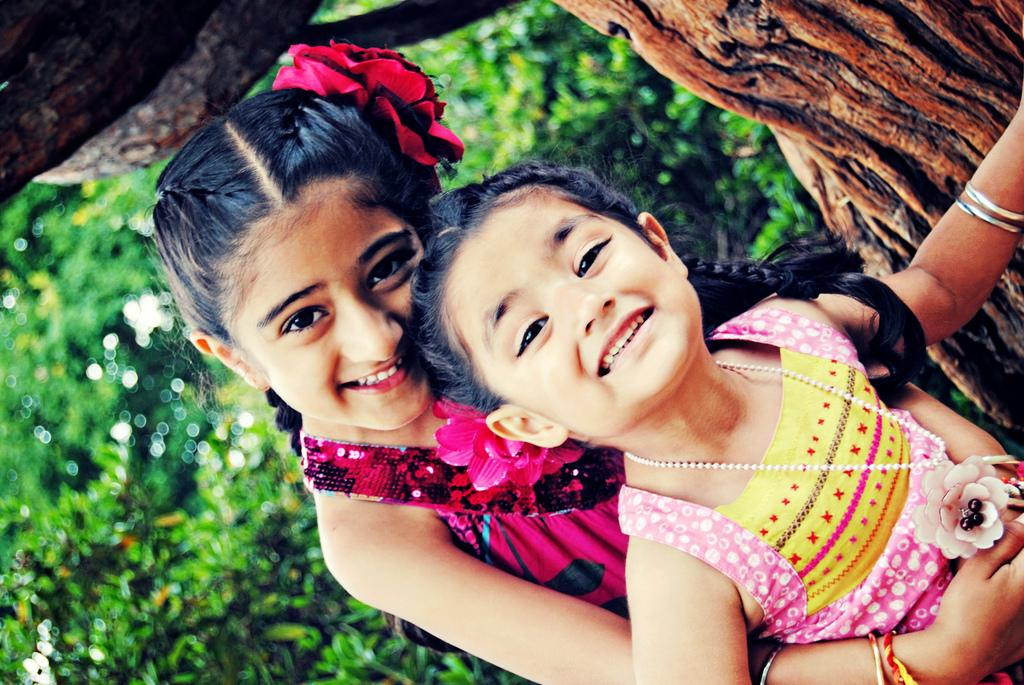What is the main subject in the center of the image? There are children in the center of the image. What is the facial expression of the children? The children are smiling. What can be seen in the background of the image? There are trees in the background of the image. What type of stick can be seen in the children's hair in the image? There is no stick present in the children's hair in the image. What design is featured on the children's clothing in the image? The provided facts do not mention any specific design on the children's clothing. 